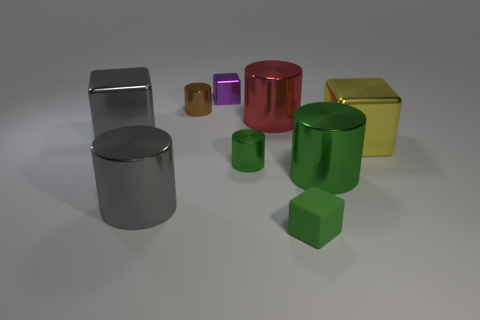Subtract all blue balls. How many green cylinders are left? 2 Subtract all purple cubes. How many cubes are left? 3 Subtract all red cylinders. How many cylinders are left? 4 Add 1 metallic cylinders. How many objects exist? 10 Subtract all red cylinders. Subtract all green spheres. How many cylinders are left? 4 Subtract all blocks. How many objects are left? 5 Add 8 red shiny objects. How many red shiny objects are left? 9 Add 2 gray spheres. How many gray spheres exist? 2 Subtract 0 blue cubes. How many objects are left? 9 Subtract all large blue metallic cubes. Subtract all cubes. How many objects are left? 5 